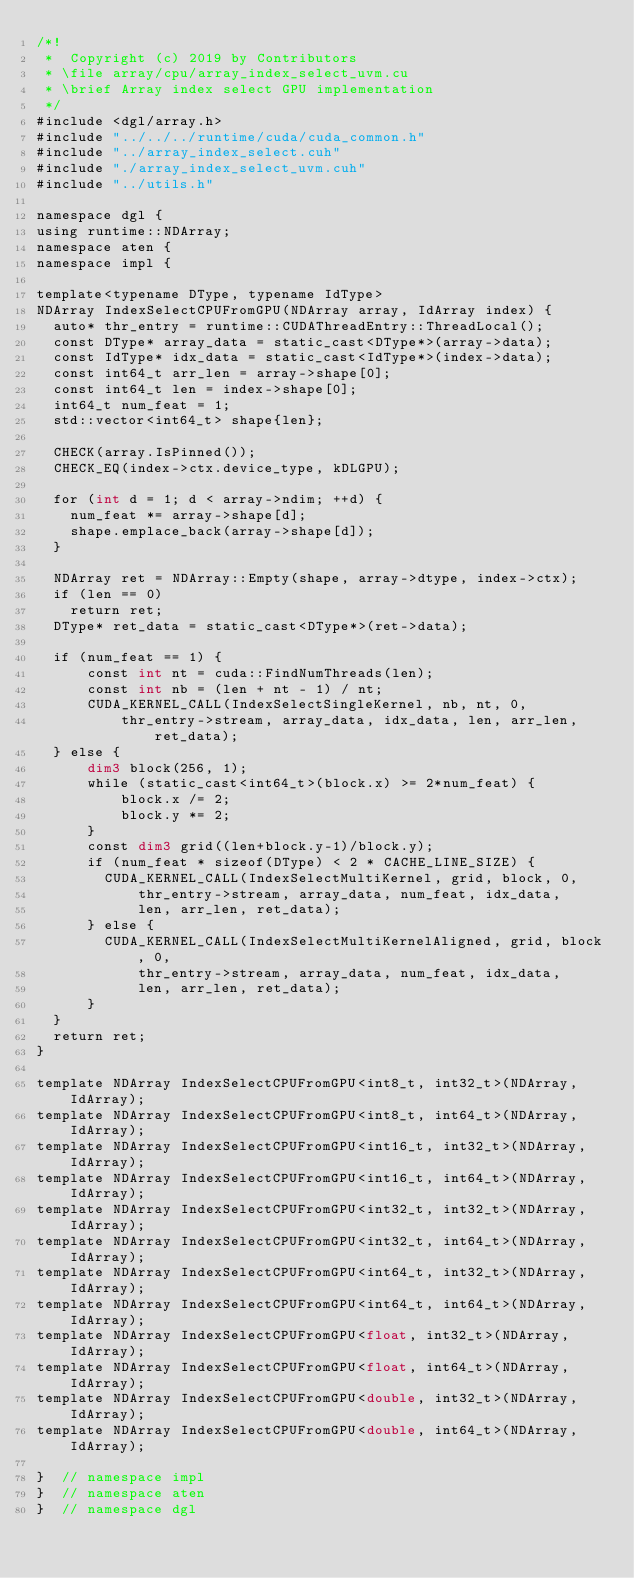Convert code to text. <code><loc_0><loc_0><loc_500><loc_500><_Cuda_>/*!
 *  Copyright (c) 2019 by Contributors
 * \file array/cpu/array_index_select_uvm.cu
 * \brief Array index select GPU implementation
 */
#include <dgl/array.h>
#include "../../../runtime/cuda/cuda_common.h"
#include "../array_index_select.cuh"
#include "./array_index_select_uvm.cuh"
#include "../utils.h"

namespace dgl {
using runtime::NDArray;
namespace aten {
namespace impl {

template<typename DType, typename IdType>
NDArray IndexSelectCPUFromGPU(NDArray array, IdArray index) {
  auto* thr_entry = runtime::CUDAThreadEntry::ThreadLocal();
  const DType* array_data = static_cast<DType*>(array->data);
  const IdType* idx_data = static_cast<IdType*>(index->data);
  const int64_t arr_len = array->shape[0];
  const int64_t len = index->shape[0];
  int64_t num_feat = 1;
  std::vector<int64_t> shape{len};

  CHECK(array.IsPinned());
  CHECK_EQ(index->ctx.device_type, kDLGPU);

  for (int d = 1; d < array->ndim; ++d) {
    num_feat *= array->shape[d];
    shape.emplace_back(array->shape[d]);
  }

  NDArray ret = NDArray::Empty(shape, array->dtype, index->ctx);
  if (len == 0)
    return ret;
  DType* ret_data = static_cast<DType*>(ret->data);

  if (num_feat == 1) {
      const int nt = cuda::FindNumThreads(len);
      const int nb = (len + nt - 1) / nt;
      CUDA_KERNEL_CALL(IndexSelectSingleKernel, nb, nt, 0,
          thr_entry->stream, array_data, idx_data, len, arr_len, ret_data);
  } else {
      dim3 block(256, 1);
      while (static_cast<int64_t>(block.x) >= 2*num_feat) {
          block.x /= 2;
          block.y *= 2;
      }
      const dim3 grid((len+block.y-1)/block.y);
      if (num_feat * sizeof(DType) < 2 * CACHE_LINE_SIZE) {
        CUDA_KERNEL_CALL(IndexSelectMultiKernel, grid, block, 0,
            thr_entry->stream, array_data, num_feat, idx_data,
            len, arr_len, ret_data);
      } else {
        CUDA_KERNEL_CALL(IndexSelectMultiKernelAligned, grid, block, 0,
            thr_entry->stream, array_data, num_feat, idx_data,
            len, arr_len, ret_data);
      }
  }
  return ret;
}

template NDArray IndexSelectCPUFromGPU<int8_t, int32_t>(NDArray, IdArray);
template NDArray IndexSelectCPUFromGPU<int8_t, int64_t>(NDArray, IdArray);
template NDArray IndexSelectCPUFromGPU<int16_t, int32_t>(NDArray, IdArray);
template NDArray IndexSelectCPUFromGPU<int16_t, int64_t>(NDArray, IdArray);
template NDArray IndexSelectCPUFromGPU<int32_t, int32_t>(NDArray, IdArray);
template NDArray IndexSelectCPUFromGPU<int32_t, int64_t>(NDArray, IdArray);
template NDArray IndexSelectCPUFromGPU<int64_t, int32_t>(NDArray, IdArray);
template NDArray IndexSelectCPUFromGPU<int64_t, int64_t>(NDArray, IdArray);
template NDArray IndexSelectCPUFromGPU<float, int32_t>(NDArray, IdArray);
template NDArray IndexSelectCPUFromGPU<float, int64_t>(NDArray, IdArray);
template NDArray IndexSelectCPUFromGPU<double, int32_t>(NDArray, IdArray);
template NDArray IndexSelectCPUFromGPU<double, int64_t>(NDArray, IdArray);

}  // namespace impl
}  // namespace aten
}  // namespace dgl
</code> 